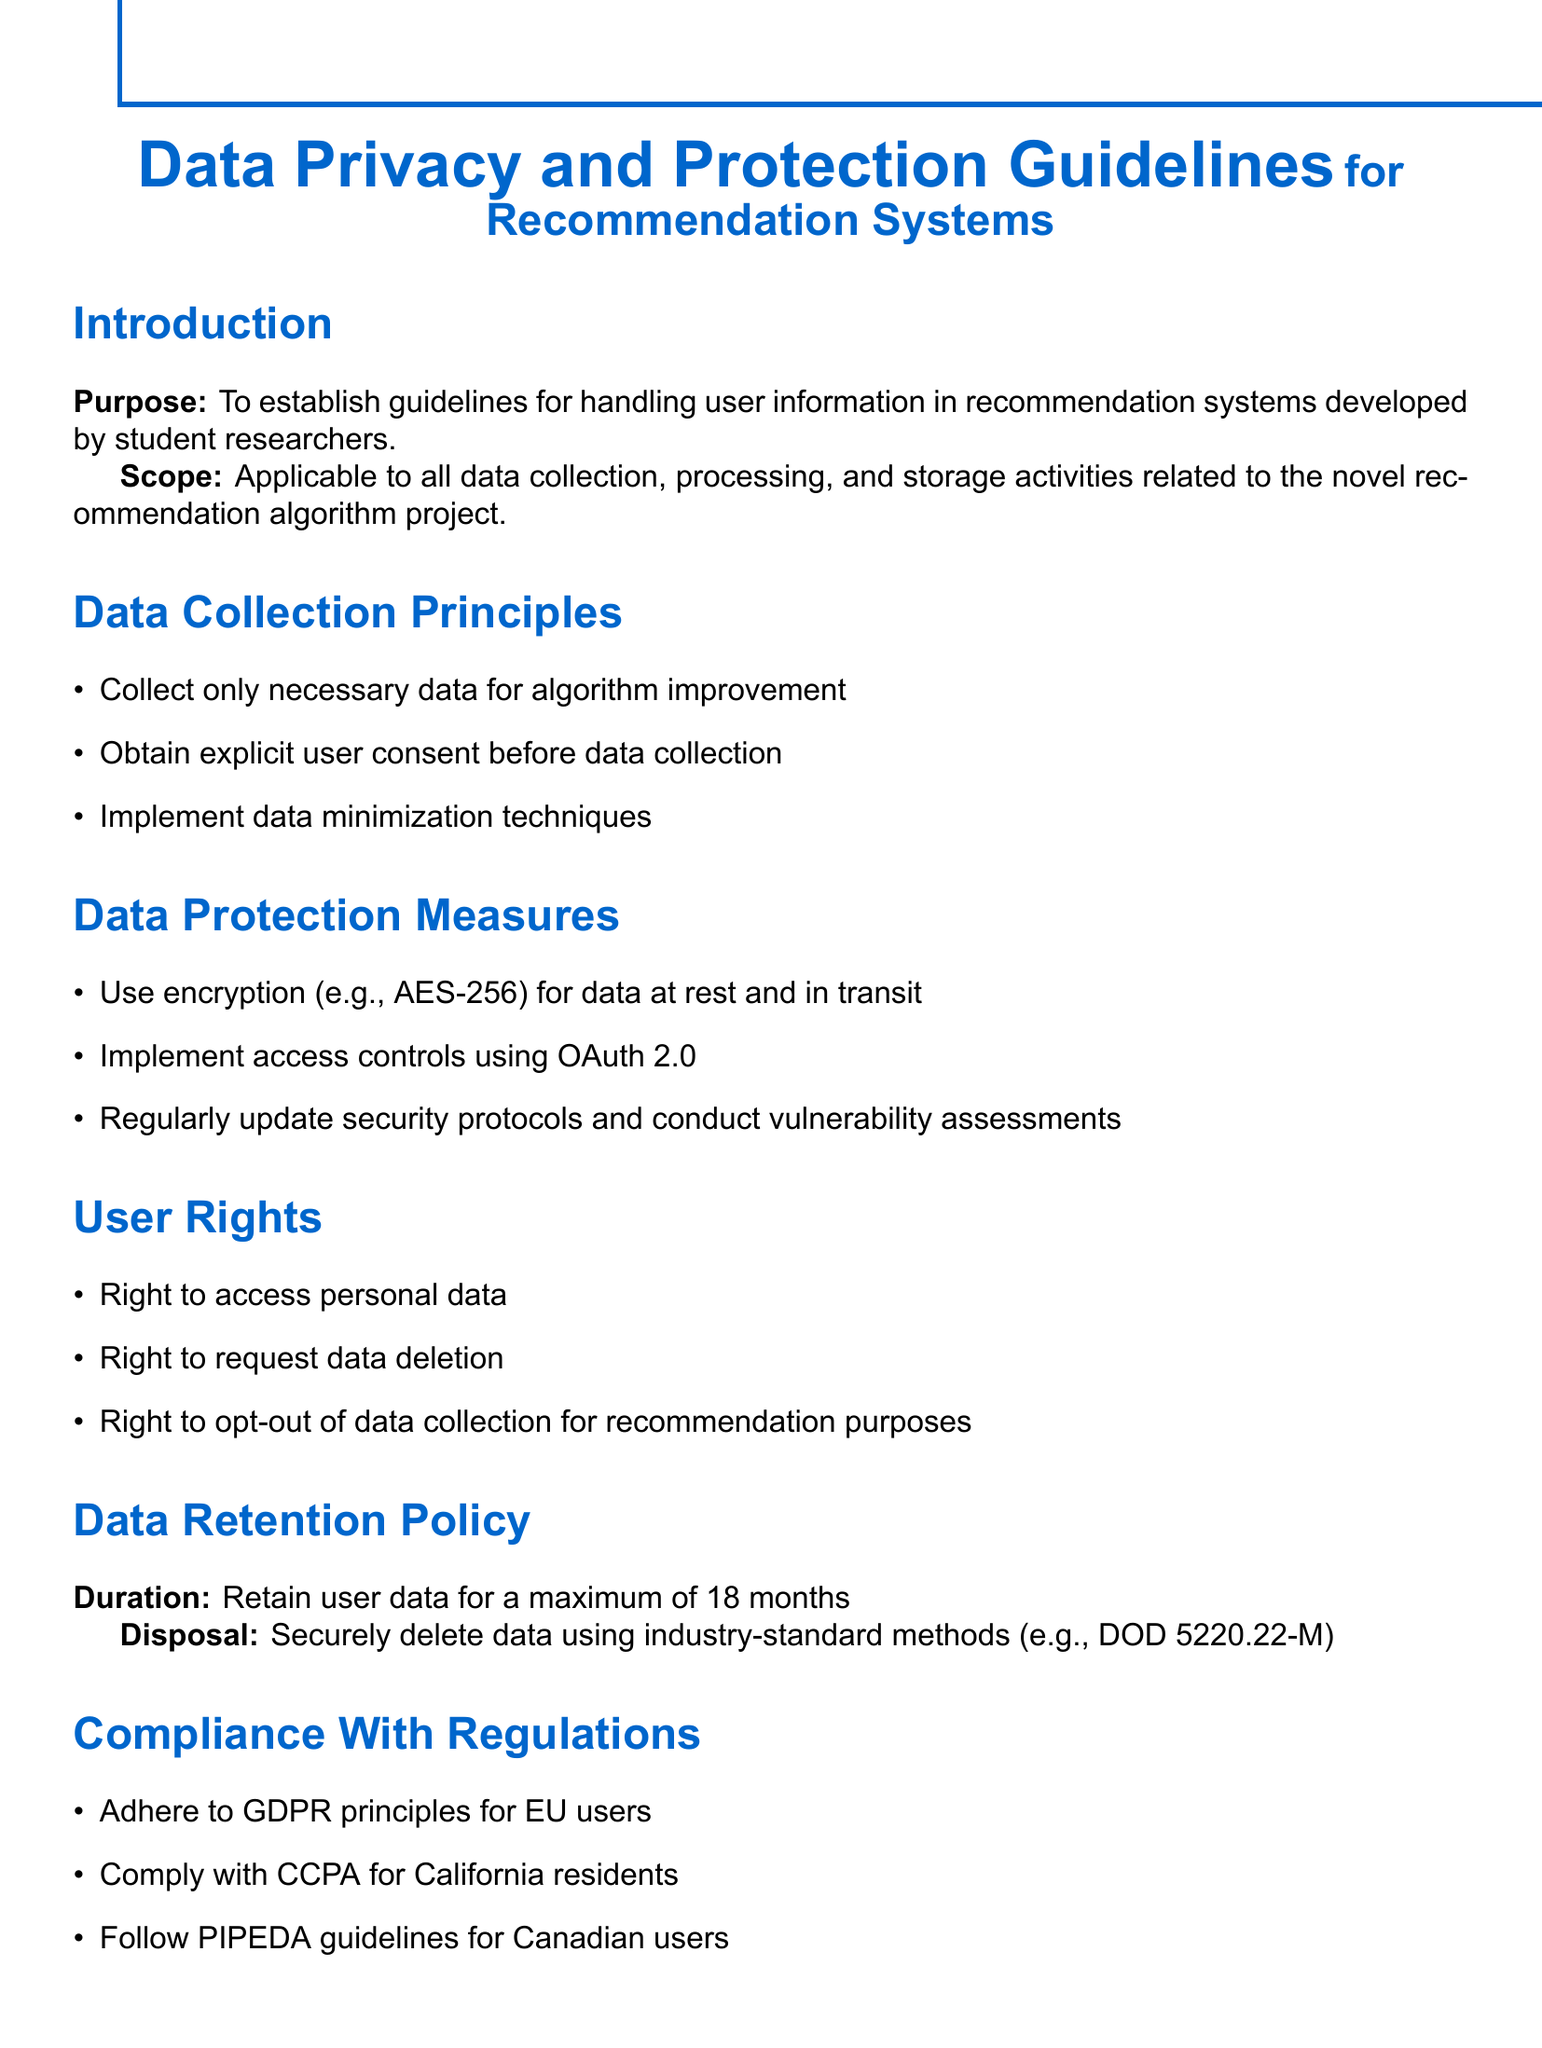What is the purpose of the document? The purpose of the document is stated in the introduction section, which is to establish guidelines for handling user information in recommendation systems developed by student researchers.
Answer: To establish guidelines for handling user information What is the maximum duration for retaining user data? The document specifies the maximum duration for retaining user data in the Data Retention Policy section.
Answer: 18 months What encryption standard should be used for data protection? The Data Protection Measures section mentions the encryption standard to be used for data protection.
Answer: AES-256 Which email is designated for contacting the Data Protection Officer? The Contact Information section lists the email for the Data Protection Officer.
Answer: privacy@universityrec.edu What right allows users to request their personal data be deleted? The User Rights section lists various rights, including the right that allows users to request deletion of their data.
Answer: Right to request data deletion What principle must be adhered to for EU users according to the document? The Compliance With Regulations section mentions the principle for EU users that must be adhered to.
Answer: GDPR principles What is the notification timeframe after a data breach discovery? The Data Breach Protocol section specifies the timeframe for notifying users after discovering a data breach.
Answer: 72 hours What should be prioritized in ethical considerations when conflicts arise? The Ethical Considerations section states what should be prioritized when conflicts arise regarding user data and algorithm performance.
Answer: User privacy 